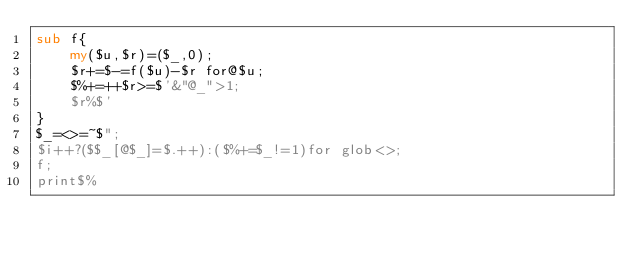Convert code to text. <code><loc_0><loc_0><loc_500><loc_500><_Perl_>sub f{
	my($u,$r)=($_,0);
	$r+=$-=f($u)-$r for@$u;
	$%+=++$r>=$'&"@_">1;
	$r%$'
}
$_=<>=~$";
$i++?($$_[@$_]=$.++):($%+=$_!=1)for glob<>;
f;
print$%</code> 